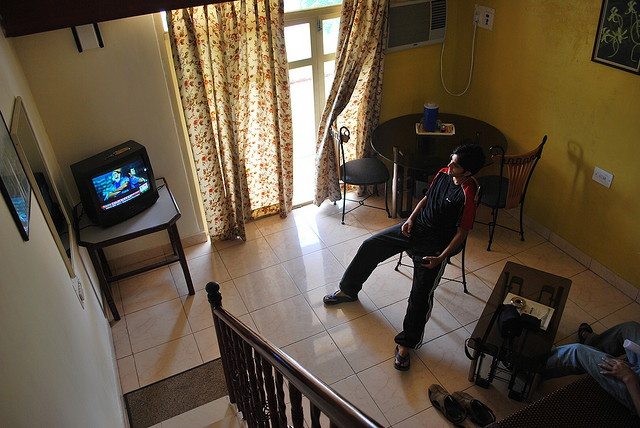Describe the objects in this image and their specific colors. I can see people in black, maroon, darkgray, and gray tones, dining table in black, maroon, and gray tones, tv in black, navy, lightblue, and blue tones, people in black, navy, darkblue, and gray tones, and couch in black and gray tones in this image. 